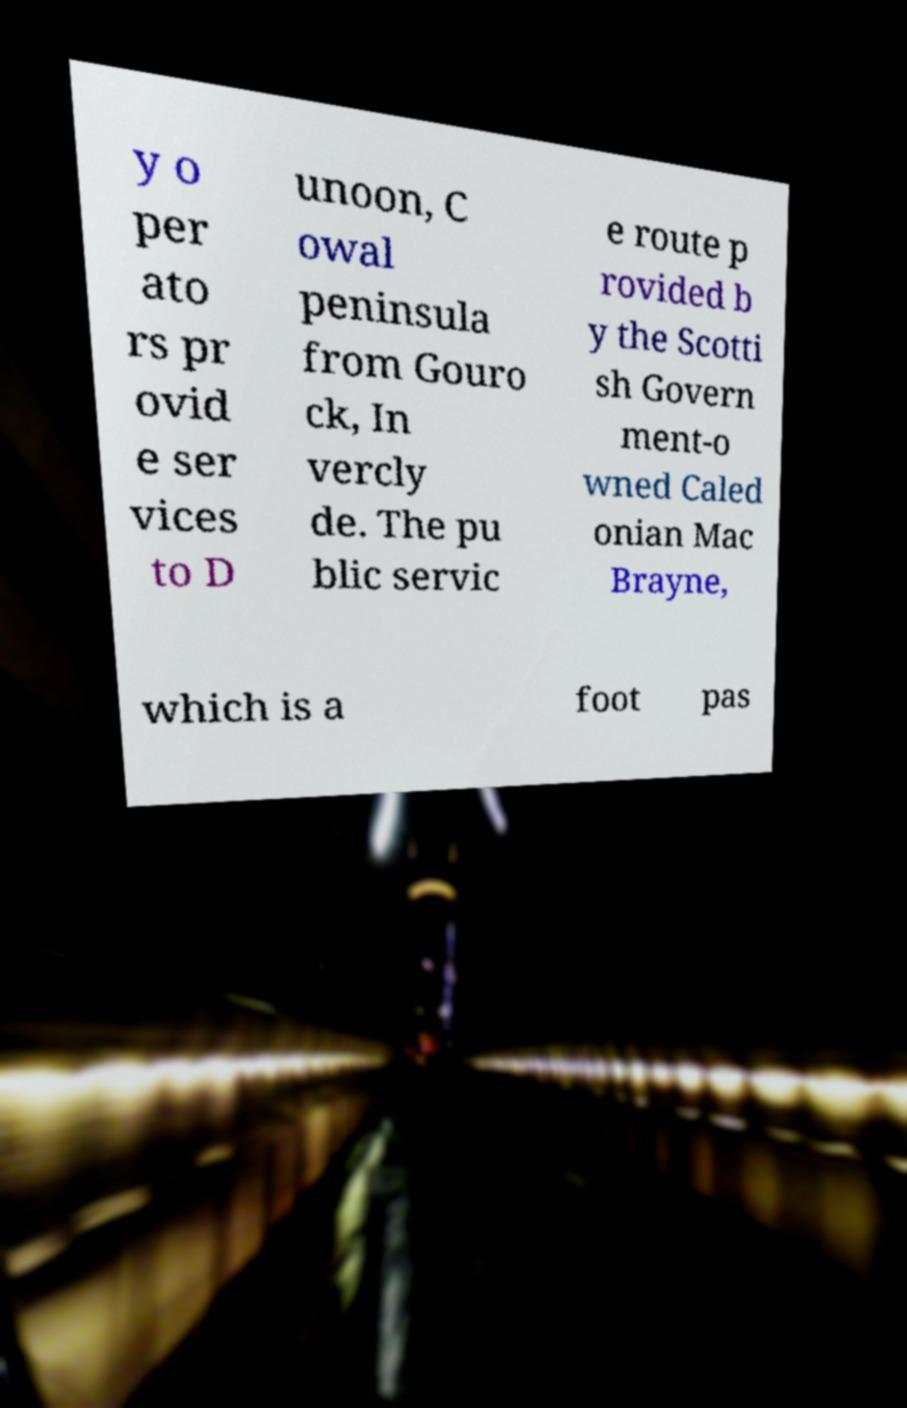Please identify and transcribe the text found in this image. y o per ato rs pr ovid e ser vices to D unoon, C owal peninsula from Gouro ck, In vercly de. The pu blic servic e route p rovided b y the Scotti sh Govern ment-o wned Caled onian Mac Brayne, which is a foot pas 